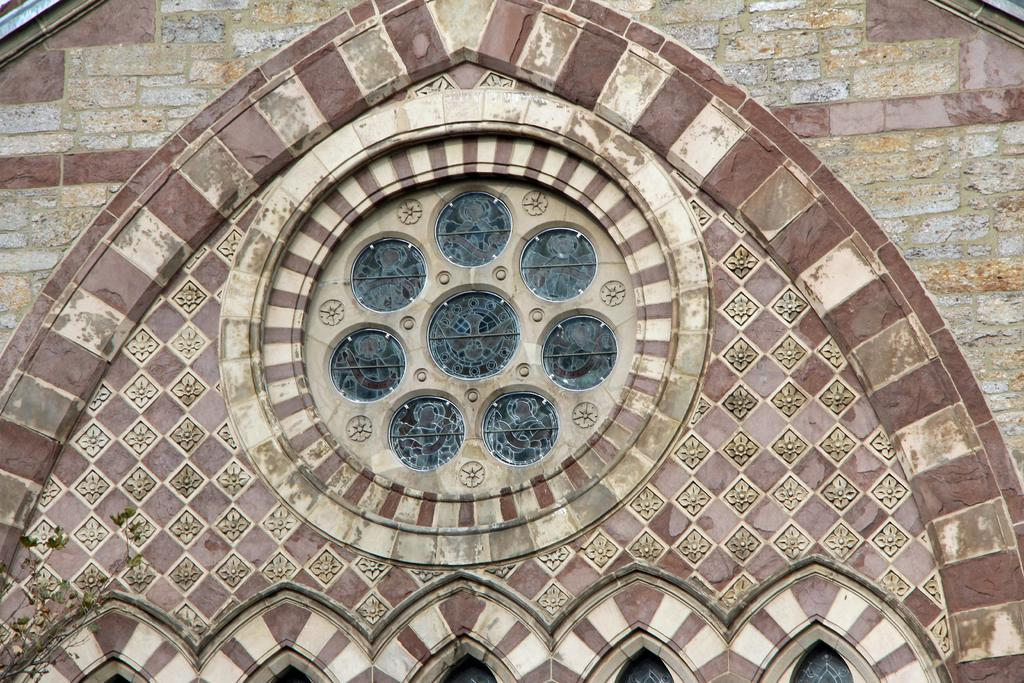What type of structure is visible in the image? There is a building in the image. Can you describe any specific architectural features of the building? Yes, there is an arch on the building. How many tigers can be seen walking along the route in the image? There are no tigers or routes visible in the image; it only features a building with an arch. 